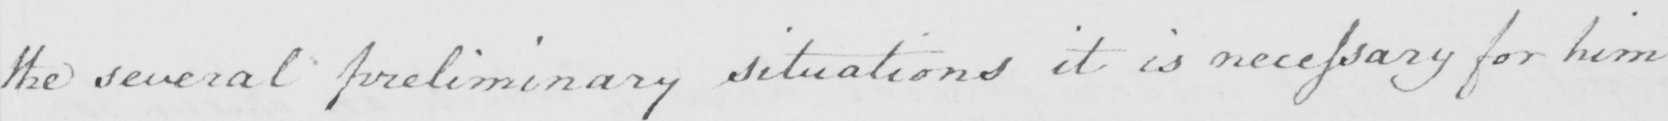Can you read and transcribe this handwriting? the several preliminary situations it is necessary for him 